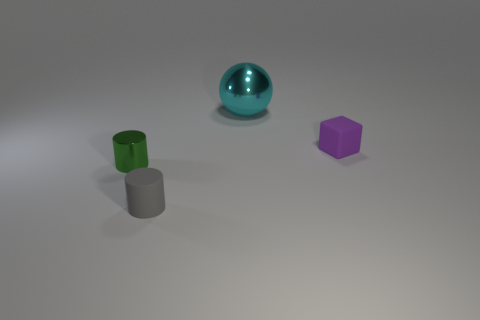Add 1 green cylinders. How many objects exist? 5 Subtract all cubes. How many objects are left? 3 Subtract 0 blue cylinders. How many objects are left? 4 Subtract all tiny purple objects. Subtract all gray objects. How many objects are left? 2 Add 2 cylinders. How many cylinders are left? 4 Add 3 yellow shiny blocks. How many yellow shiny blocks exist? 3 